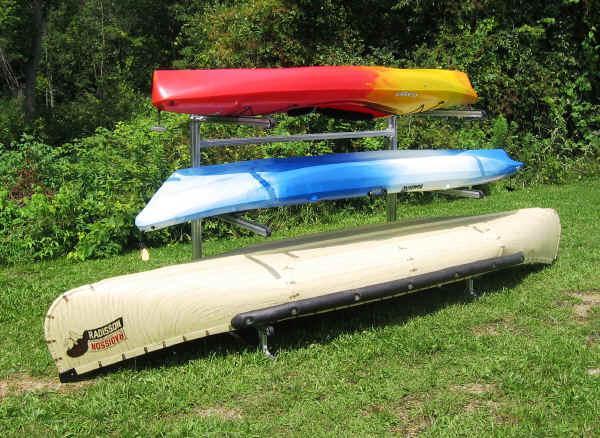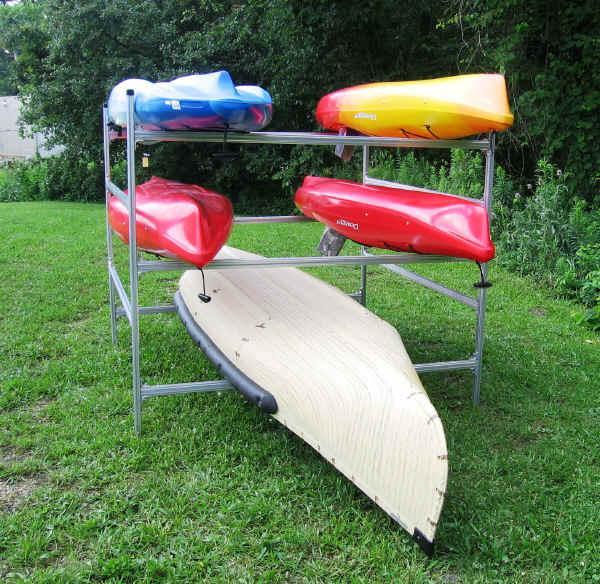The first image is the image on the left, the second image is the image on the right. Given the left and right images, does the statement "3 canoes are stacked on a platform" hold true? Answer yes or no. Yes. The first image is the image on the left, the second image is the image on the right. For the images displayed, is the sentence "At least two of the canoes are green." factually correct? Answer yes or no. No. 